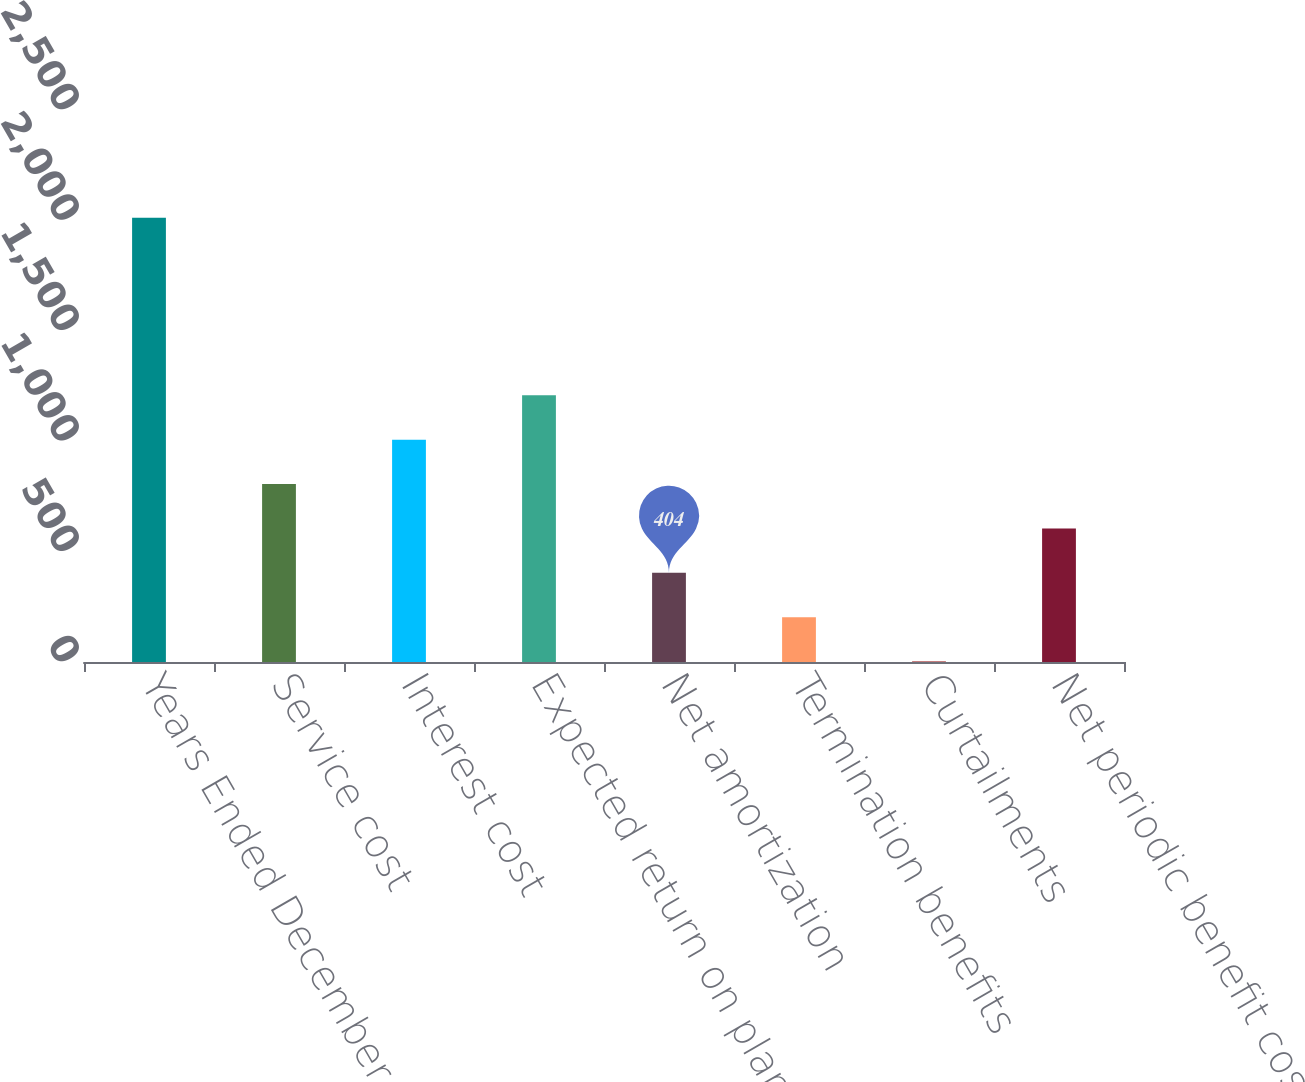Convert chart. <chart><loc_0><loc_0><loc_500><loc_500><bar_chart><fcel>Years Ended December 31<fcel>Service cost<fcel>Interest cost<fcel>Expected return on plan assets<fcel>Net amortization<fcel>Termination benefits<fcel>Curtailments<fcel>Net periodic benefit cost<nl><fcel>2012<fcel>806<fcel>1007<fcel>1208<fcel>404<fcel>203<fcel>2<fcel>605<nl></chart> 